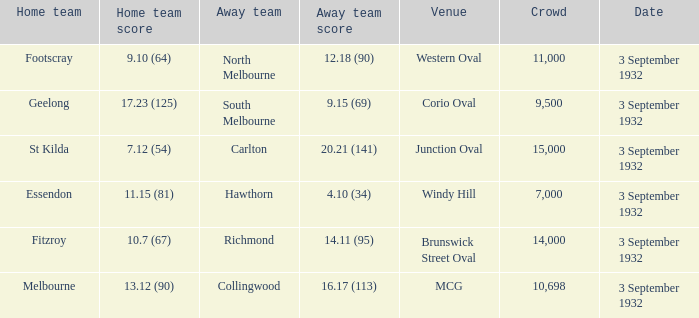What date is listed for the team that has an Away team score of 20.21 (141)? 3 September 1932. 